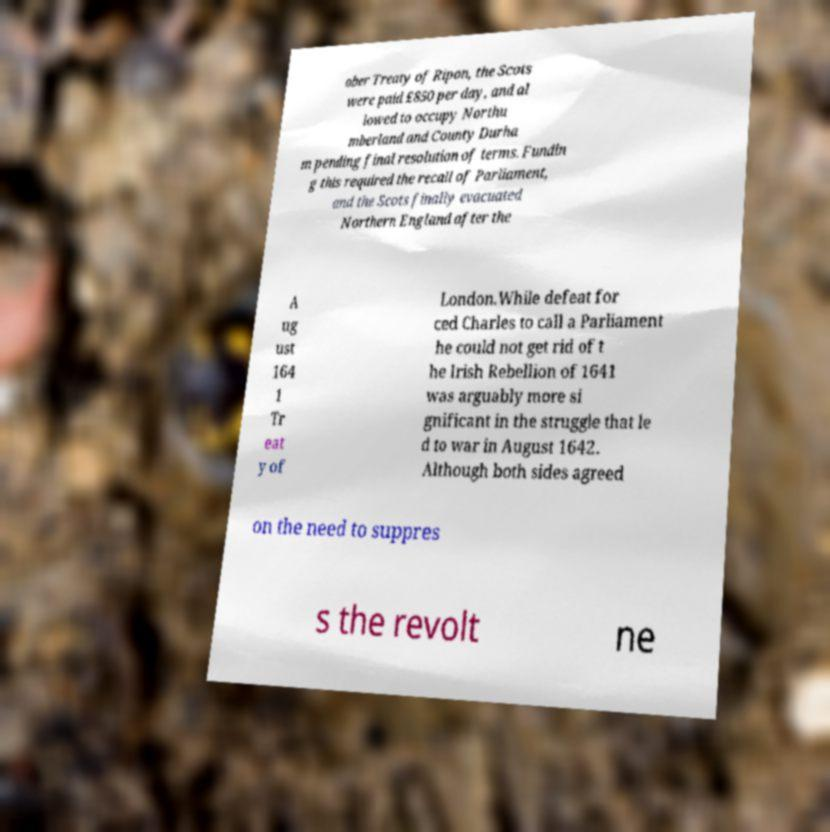Can you read and provide the text displayed in the image?This photo seems to have some interesting text. Can you extract and type it out for me? ober Treaty of Ripon, the Scots were paid £850 per day, and al lowed to occupy Northu mberland and County Durha m pending final resolution of terms. Fundin g this required the recall of Parliament, and the Scots finally evacuated Northern England after the A ug ust 164 1 Tr eat y of London.While defeat for ced Charles to call a Parliament he could not get rid of t he Irish Rebellion of 1641 was arguably more si gnificant in the struggle that le d to war in August 1642. Although both sides agreed on the need to suppres s the revolt ne 